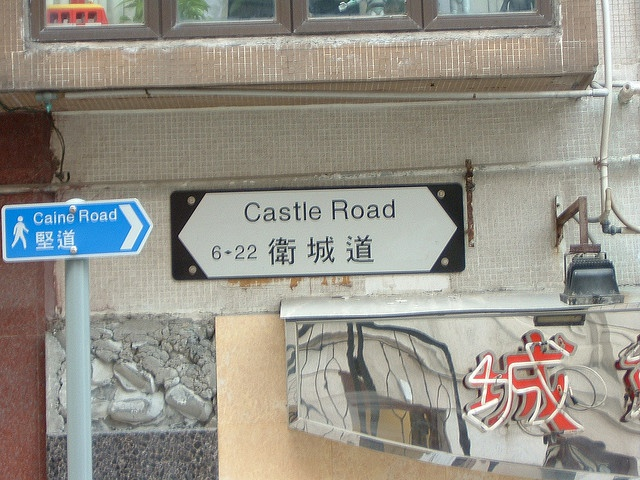Describe the objects in this image and their specific colors. I can see various objects in this image with different colors. 